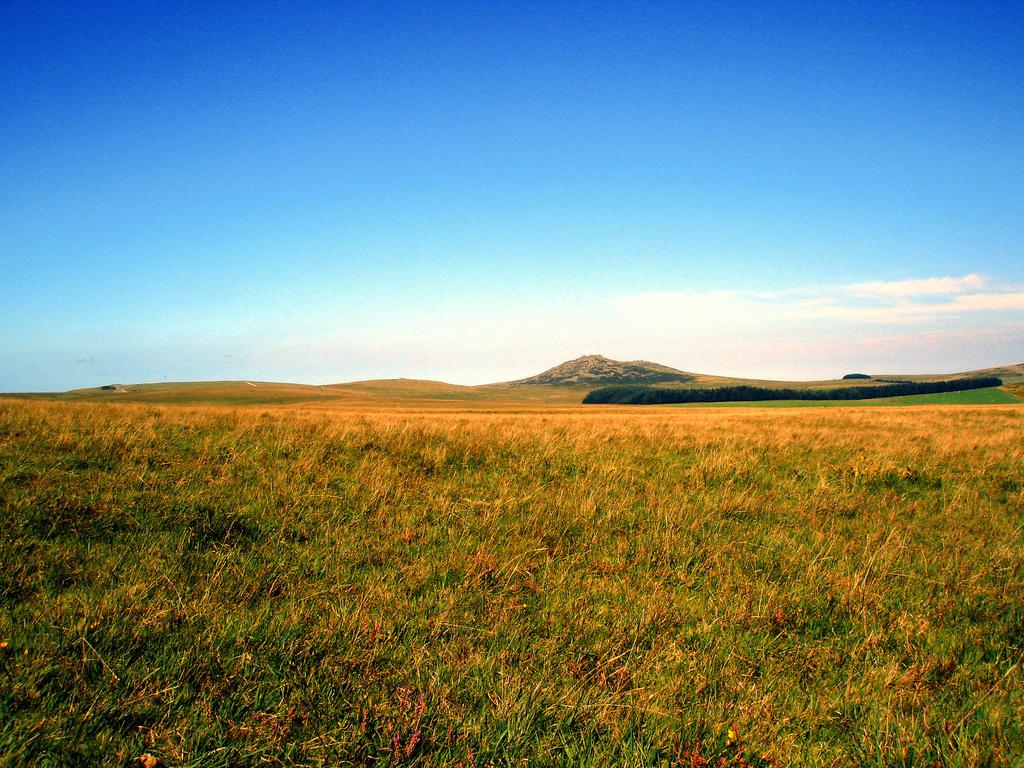What type of vegetation can be seen in the image? There is grass in the image. What other natural elements are present in the image? There are trees and hills in the image. What is visible in the background of the image? The sky is visible in the image. What can be seen in the sky? Clouds are present in the sky. How many children are playing on the hills in the image? There are no children present in the image; it only features grass, trees, hills, sky, and clouds. 